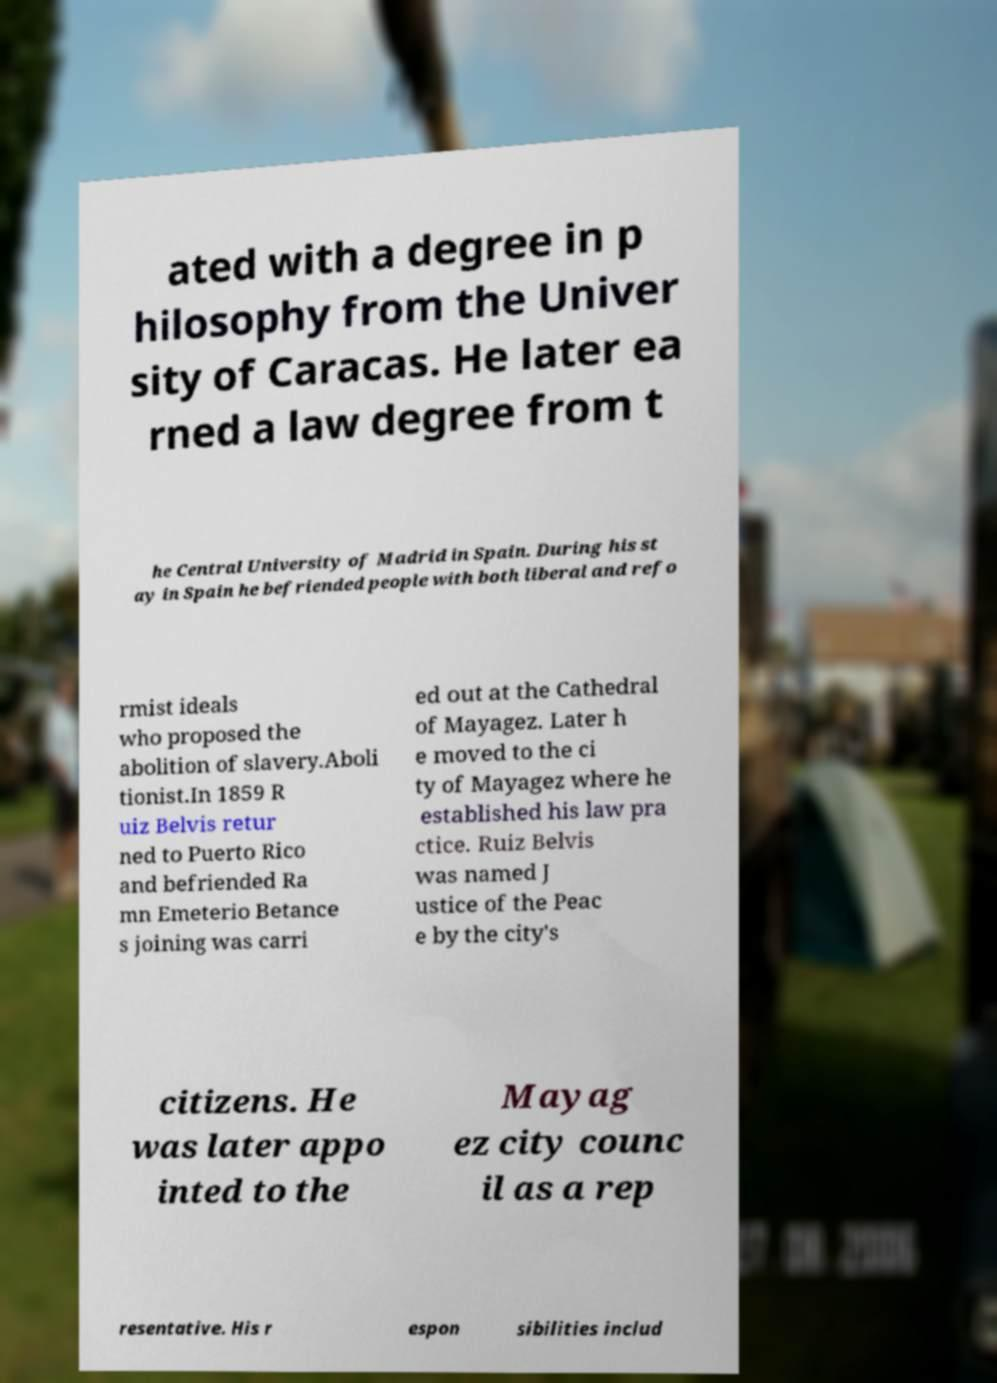Could you extract and type out the text from this image? ated with a degree in p hilosophy from the Univer sity of Caracas. He later ea rned a law degree from t he Central University of Madrid in Spain. During his st ay in Spain he befriended people with both liberal and refo rmist ideals who proposed the abolition of slavery.Aboli tionist.In 1859 R uiz Belvis retur ned to Puerto Rico and befriended Ra mn Emeterio Betance s joining was carri ed out at the Cathedral of Mayagez. Later h e moved to the ci ty of Mayagez where he established his law pra ctice. Ruiz Belvis was named J ustice of the Peac e by the city's citizens. He was later appo inted to the Mayag ez city counc il as a rep resentative. His r espon sibilities includ 